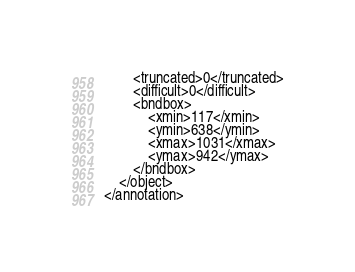<code> <loc_0><loc_0><loc_500><loc_500><_XML_>		<truncated>0</truncated>
		<difficult>0</difficult>
		<bndbox>
			<xmin>117</xmin>
			<ymin>638</ymin>
			<xmax>1031</xmax>
			<ymax>942</ymax>
		</bndbox>
	</object>
</annotation>
</code> 